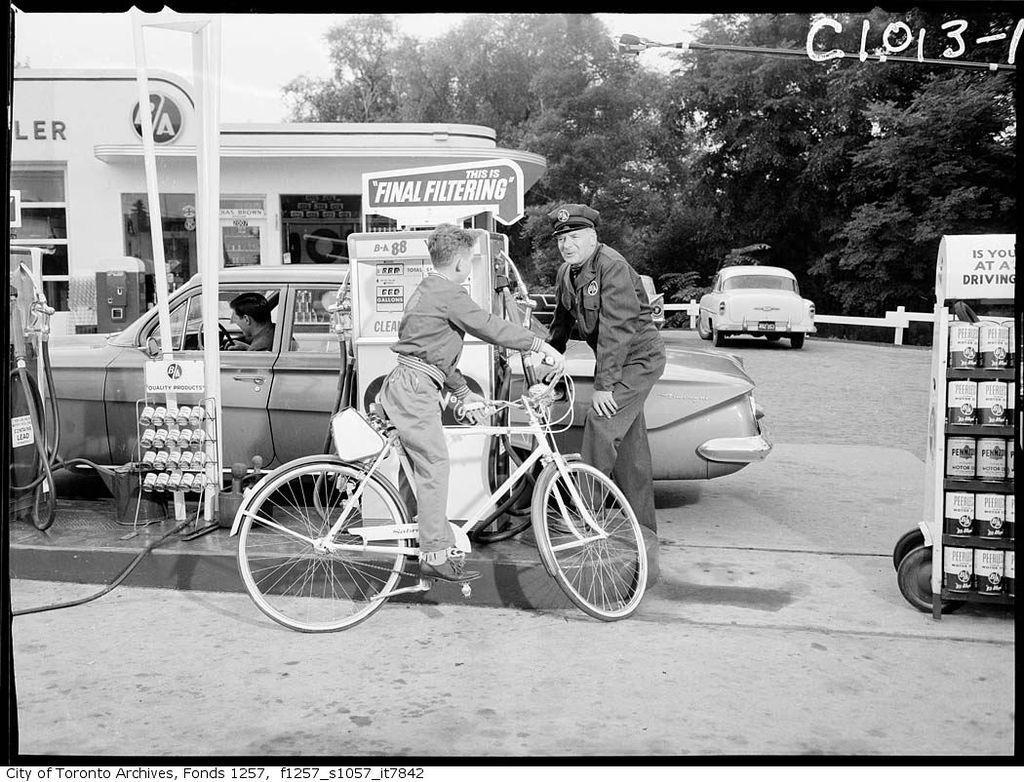Please provide a concise description of this image. In the center of the image we can see a boy riding a bicycle. In the background there is a man standing and we can see cars. On the left there is a building. There are trees. At the top there is sky. On the right there is a trolley. 